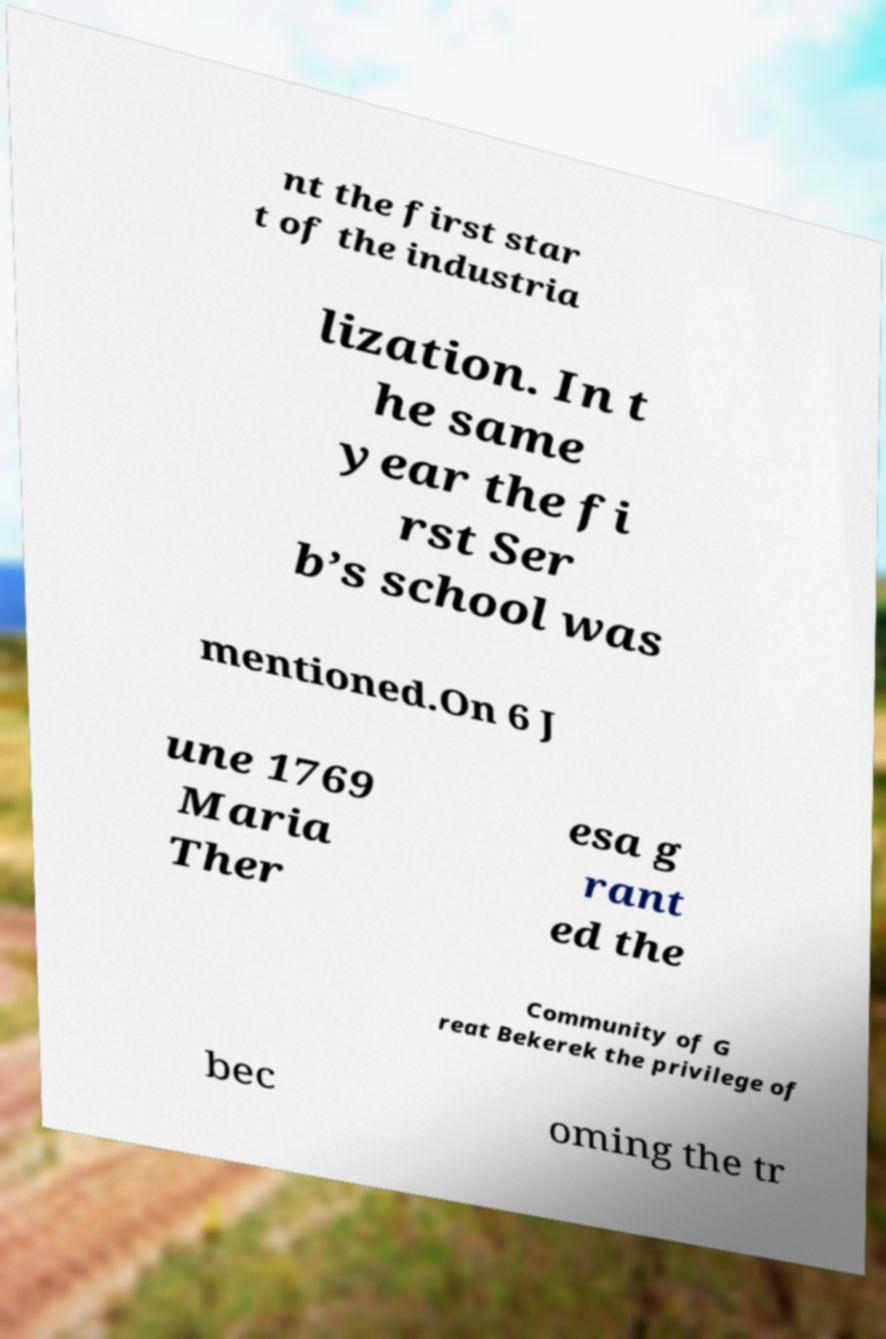Can you accurately transcribe the text from the provided image for me? nt the first star t of the industria lization. In t he same year the fi rst Ser b’s school was mentioned.On 6 J une 1769 Maria Ther esa g rant ed the Community of G reat Bekerek the privilege of bec oming the tr 